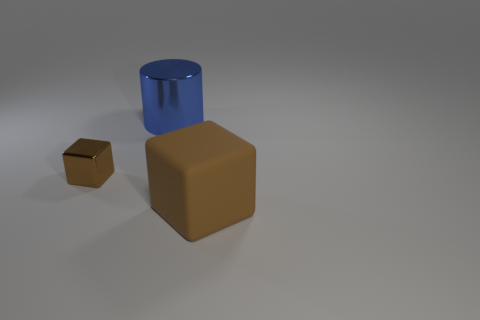Add 2 small cyan rubber objects. How many objects exist? 5 Subtract all cubes. How many objects are left? 1 Subtract 0 red cylinders. How many objects are left? 3 Subtract all big brown matte things. Subtract all blue shiny cylinders. How many objects are left? 1 Add 1 tiny brown blocks. How many tiny brown blocks are left? 2 Add 1 big brown matte cubes. How many big brown matte cubes exist? 2 